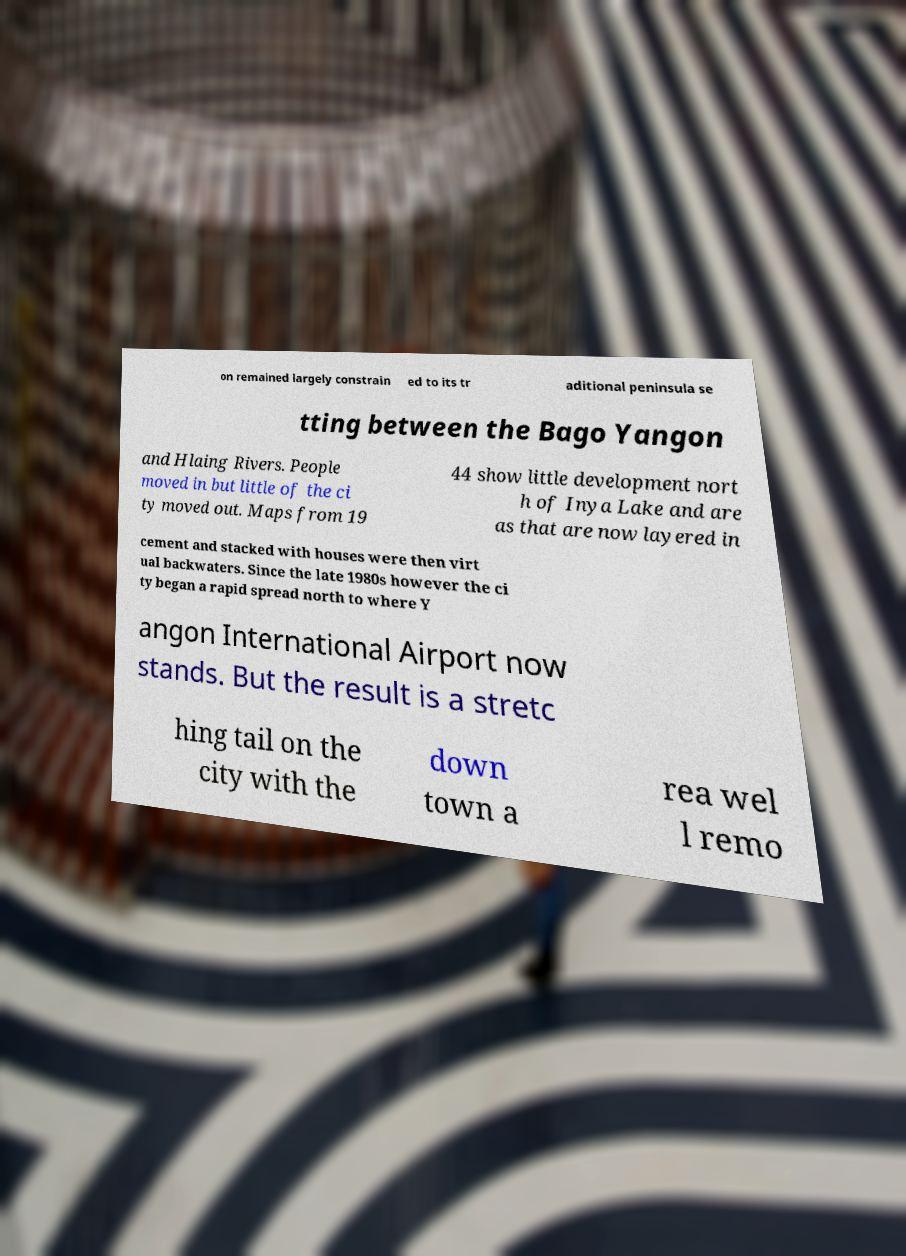Can you accurately transcribe the text from the provided image for me? on remained largely constrain ed to its tr aditional peninsula se tting between the Bago Yangon and Hlaing Rivers. People moved in but little of the ci ty moved out. Maps from 19 44 show little development nort h of Inya Lake and are as that are now layered in cement and stacked with houses were then virt ual backwaters. Since the late 1980s however the ci ty began a rapid spread north to where Y angon International Airport now stands. But the result is a stretc hing tail on the city with the down town a rea wel l remo 